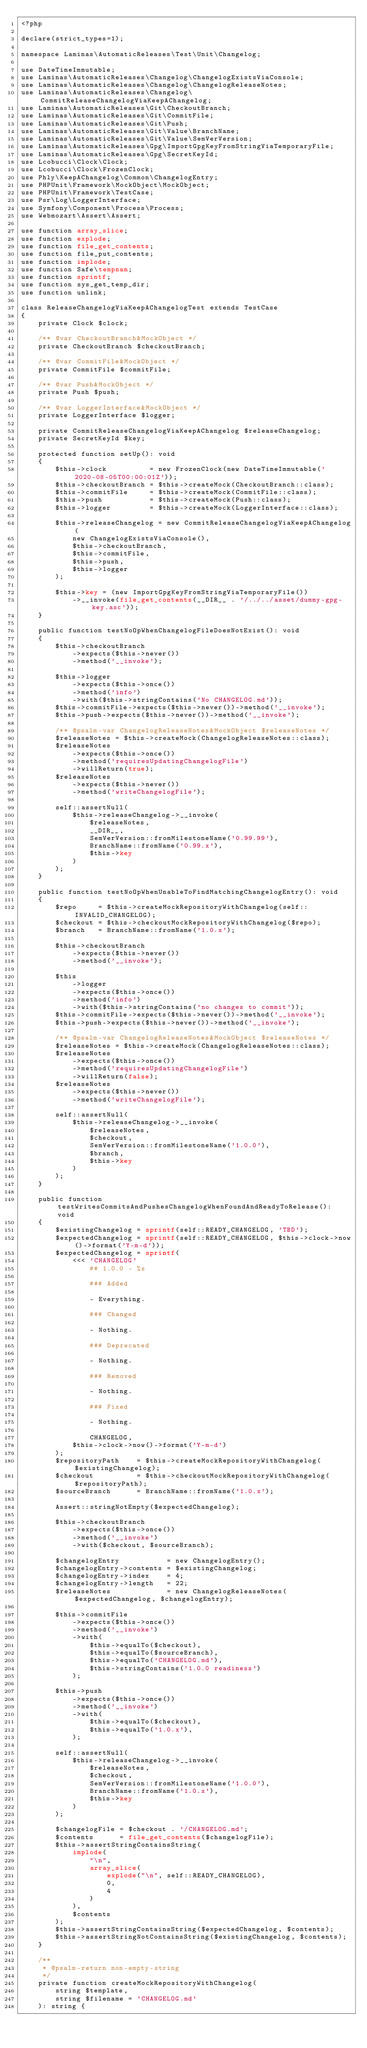Convert code to text. <code><loc_0><loc_0><loc_500><loc_500><_PHP_><?php

declare(strict_types=1);

namespace Laminas\AutomaticReleases\Test\Unit\Changelog;

use DateTimeImmutable;
use Laminas\AutomaticReleases\Changelog\ChangelogExistsViaConsole;
use Laminas\AutomaticReleases\Changelog\ChangelogReleaseNotes;
use Laminas\AutomaticReleases\Changelog\CommitReleaseChangelogViaKeepAChangelog;
use Laminas\AutomaticReleases\Git\CheckoutBranch;
use Laminas\AutomaticReleases\Git\CommitFile;
use Laminas\AutomaticReleases\Git\Push;
use Laminas\AutomaticReleases\Git\Value\BranchName;
use Laminas\AutomaticReleases\Git\Value\SemVerVersion;
use Laminas\AutomaticReleases\Gpg\ImportGpgKeyFromStringViaTemporaryFile;
use Laminas\AutomaticReleases\Gpg\SecretKeyId;
use Lcobucci\Clock\Clock;
use Lcobucci\Clock\FrozenClock;
use Phly\KeepAChangelog\Common\ChangelogEntry;
use PHPUnit\Framework\MockObject\MockObject;
use PHPUnit\Framework\TestCase;
use Psr\Log\LoggerInterface;
use Symfony\Component\Process\Process;
use Webmozart\Assert\Assert;

use function array_slice;
use function explode;
use function file_get_contents;
use function file_put_contents;
use function implode;
use function Safe\tempnam;
use function sprintf;
use function sys_get_temp_dir;
use function unlink;

class ReleaseChangelogViaKeepAChangelogTest extends TestCase
{
    private Clock $clock;

    /** @var CheckoutBranch&MockObject */
    private CheckoutBranch $checkoutBranch;

    /** @var CommitFile&MockObject */
    private CommitFile $commitFile;

    /** @var Push&MockObject */
    private Push $push;

    /** @var LoggerInterface&MockObject */
    private LoggerInterface $logger;

    private CommitReleaseChangelogViaKeepAChangelog $releaseChangelog;
    private SecretKeyId $key;

    protected function setUp(): void
    {
        $this->clock          = new FrozenClock(new DateTimeImmutable('2020-08-05T00:00:01Z'));
        $this->checkoutBranch = $this->createMock(CheckoutBranch::class);
        $this->commitFile     = $this->createMock(CommitFile::class);
        $this->push           = $this->createMock(Push::class);
        $this->logger         = $this->createMock(LoggerInterface::class);

        $this->releaseChangelog = new CommitReleaseChangelogViaKeepAChangelog(
            new ChangelogExistsViaConsole(),
            $this->checkoutBranch,
            $this->commitFile,
            $this->push,
            $this->logger
        );

        $this->key = (new ImportGpgKeyFromStringViaTemporaryFile())
            ->__invoke(file_get_contents(__DIR__ . '/../../asset/dummy-gpg-key.asc'));
    }

    public function testNoOpWhenChangelogFileDoesNotExist(): void
    {
        $this->checkoutBranch
            ->expects($this->never())
            ->method('__invoke');

        $this->logger
            ->expects($this->once())
            ->method('info')
            ->with($this->stringContains('No CHANGELOG.md'));
        $this->commitFile->expects($this->never())->method('__invoke');
        $this->push->expects($this->never())->method('__invoke');

        /** @psalm-var ChangelogReleaseNotes&MockObject $releaseNotes */
        $releaseNotes = $this->createMock(ChangelogReleaseNotes::class);
        $releaseNotes
            ->expects($this->once())
            ->method('requiresUpdatingChangelogFile')
            ->willReturn(true);
        $releaseNotes
            ->expects($this->never())
            ->method('writeChangelogFile');

        self::assertNull(
            $this->releaseChangelog->__invoke(
                $releaseNotes,
                __DIR__,
                SemVerVersion::fromMilestoneName('0.99.99'),
                BranchName::fromName('0.99.x'),
                $this->key
            )
        );
    }

    public function testNoOpWhenUnableToFindMatchingChangelogEntry(): void
    {
        $repo     = $this->createMockRepositoryWithChangelog(self::INVALID_CHANGELOG);
        $checkout = $this->checkoutMockRepositoryWithChangelog($repo);
        $branch   = BranchName::fromName('1.0.x');

        $this->checkoutBranch
            ->expects($this->never())
            ->method('__invoke');

        $this
            ->logger
            ->expects($this->once())
            ->method('info')
            ->with($this->stringContains('no changes to commit'));
        $this->commitFile->expects($this->never())->method('__invoke');
        $this->push->expects($this->never())->method('__invoke');

        /** @psalm-var ChangelogReleaseNotes&MockObject $releaseNotes */
        $releaseNotes = $this->createMock(ChangelogReleaseNotes::class);
        $releaseNotes
            ->expects($this->once())
            ->method('requiresUpdatingChangelogFile')
            ->willReturn(false);
        $releaseNotes
            ->expects($this->never())
            ->method('writeChangelogFile');

        self::assertNull(
            $this->releaseChangelog->__invoke(
                $releaseNotes,
                $checkout,
                SemVerVersion::fromMilestoneName('1.0.0'),
                $branch,
                $this->key
            )
        );
    }

    public function testWritesCommitsAndPushesChangelogWhenFoundAndReadyToRelease(): void
    {
        $existingChangelog = sprintf(self::READY_CHANGELOG, 'TBD');
        $expectedChangelog = sprintf(self::READY_CHANGELOG, $this->clock->now()->format('Y-m-d'));
        $expectedChangelog = sprintf(
            <<< 'CHANGELOG'
                ## 1.0.0 - %s
                
                ### Added
                
                - Everything.
                
                ### Changed
                
                - Nothing.
                
                ### Deprecated
                
                - Nothing.
                
                ### Removed
                
                - Nothing.
                
                ### Fixed
                
                - Nothing.
                
                CHANGELOG,
            $this->clock->now()->format('Y-m-d')
        );
        $repositoryPath    = $this->createMockRepositoryWithChangelog($existingChangelog);
        $checkout          = $this->checkoutMockRepositoryWithChangelog($repositoryPath);
        $sourceBranch      = BranchName::fromName('1.0.x');

        Assert::stringNotEmpty($expectedChangelog);

        $this->checkoutBranch
            ->expects($this->once())
            ->method('__invoke')
            ->with($checkout, $sourceBranch);

        $changelogEntry           = new ChangelogEntry();
        $changelogEntry->contents = $existingChangelog;
        $changelogEntry->index    = 4;
        $changelogEntry->length   = 22;
        $releaseNotes             = new ChangelogReleaseNotes($expectedChangelog, $changelogEntry);

        $this->commitFile
            ->expects($this->once())
            ->method('__invoke')
            ->with(
                $this->equalTo($checkout),
                $this->equalTo($sourceBranch),
                $this->equalTo('CHANGELOG.md'),
                $this->stringContains('1.0.0 readiness')
            );

        $this->push
            ->expects($this->once())
            ->method('__invoke')
            ->with(
                $this->equalTo($checkout),
                $this->equalTo('1.0.x'),
            );

        self::assertNull(
            $this->releaseChangelog->__invoke(
                $releaseNotes,
                $checkout,
                SemVerVersion::fromMilestoneName('1.0.0'),
                BranchName::fromName('1.0.x'),
                $this->key
            )
        );

        $changelogFile = $checkout . '/CHANGELOG.md';
        $contents      = file_get_contents($changelogFile);
        $this->assertStringContainsString(
            implode(
                "\n",
                array_slice(
                    explode("\n", self::READY_CHANGELOG),
                    0,
                    4
                )
            ),
            $contents
        );
        $this->assertStringContainsString($expectedChangelog, $contents);
        $this->assertStringNotContainsString($existingChangelog, $contents);
    }

    /**
     * @psalm-return non-empty-string
     */
    private function createMockRepositoryWithChangelog(
        string $template,
        string $filename = 'CHANGELOG.md'
    ): string {</code> 